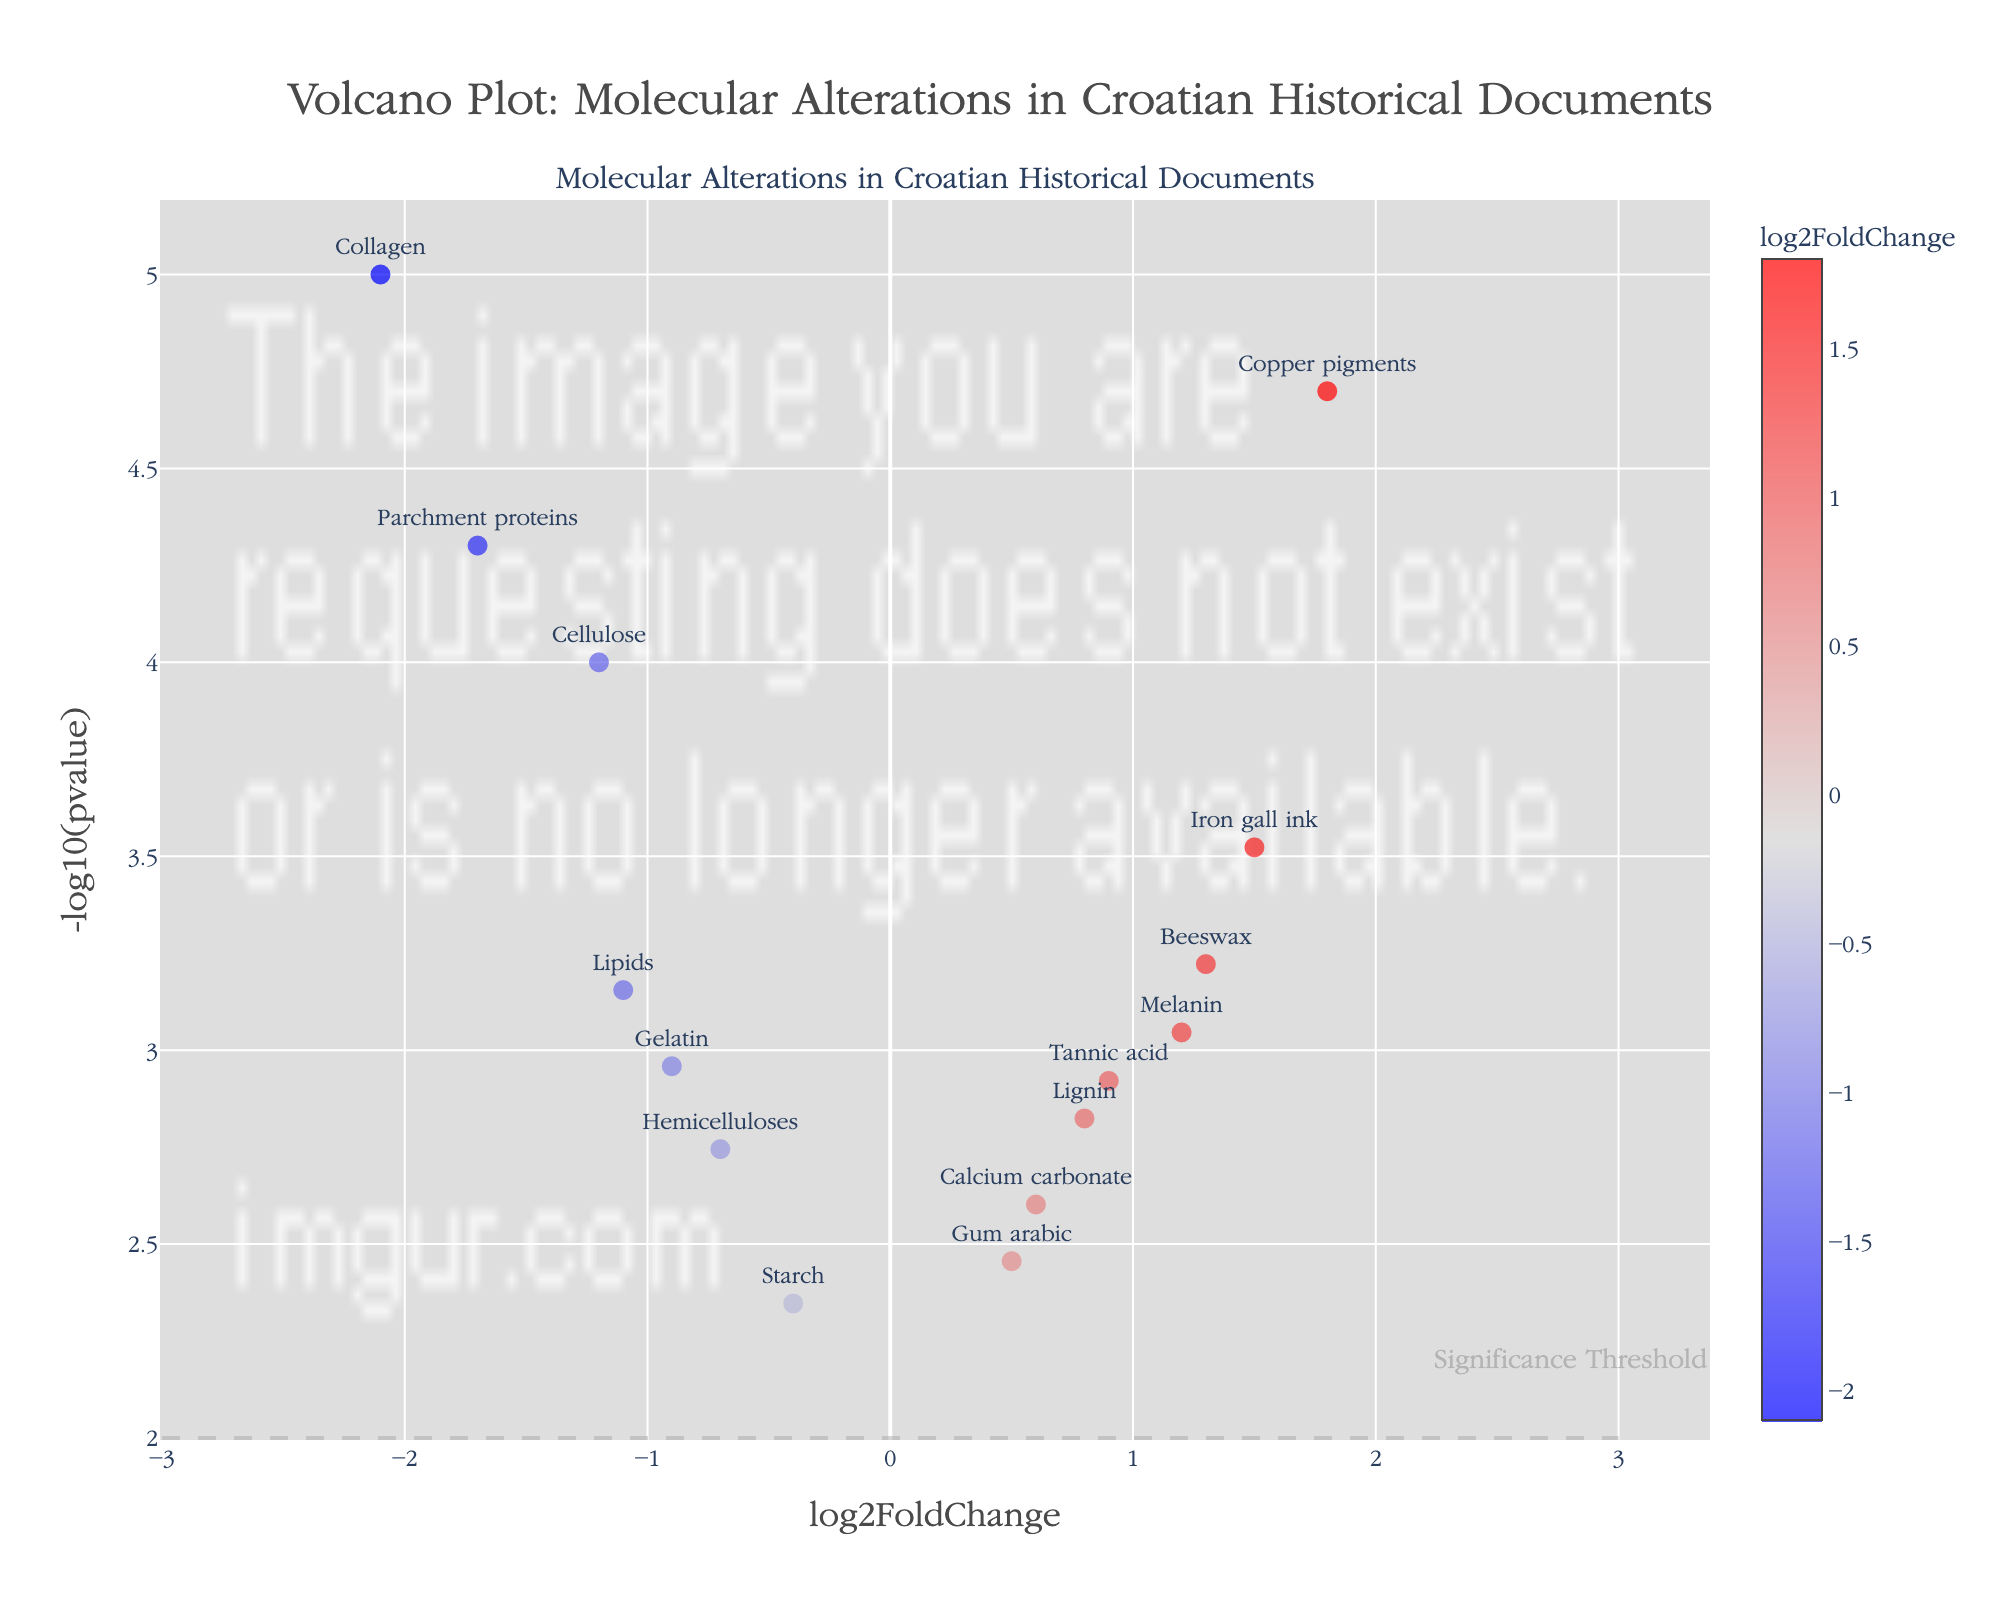How many data points have a positive log2FoldChange? Looking at the plot, count the number of markers to the right of the y-axis representing positive log2FoldChange values.
Answer: 7 What is the title of the plot? The text at the top of the plot indicates its title.
Answer: Volcano Plot: Molecular Alterations in Croatian Historical Documents Which molecular alteration has the highest -log10(pvalue)? Identify the point with the highest position on the y-axis and refer to its label.
Answer: Collagen What is the log2FoldChange value for Cellulose? Locate the marker labeled "Cellulose" and read its position on the x-axis.
Answer: -1.2 Among the genes with negative log2FoldChange, which one has the lowest p-value? Find the marker with the most negative log2FoldChange, then look for the corresponding lowest y-coordinate (highest -log10(pvalue)).
Answer: Collagen How many markers are displayed on the figure? Count all the data points (markers) on the plot.
Answer: 14 Which color represents the highest log2FoldChange values? Refer to the color scale shown on the plot to identify which color corresponds to the highest values.
Answer: Red What is the range of -log10(pvalue) shown on the y-axis? Observe the y-axis to determine the minimum and maximum values displayed.
Answer: 2 to 5 Which molecular alteration has the highest positive log2FoldChange? Look for the marker with the highest value on the right side of the x-axis and refer to its label.
Answer: Copper pigments What is the typical log2FoldChange value for markers with significant molecular alteration? Significant alterations are above the dashed line. Identify their log2FoldChange values and find the common value range.
Answer: Varies from -2.1 to 1.8 Which molecular alteration has a log2FoldChange closest to 0? Locate the marker nearest to the center (x-axis) around 0.
Answer: Gum arabic 